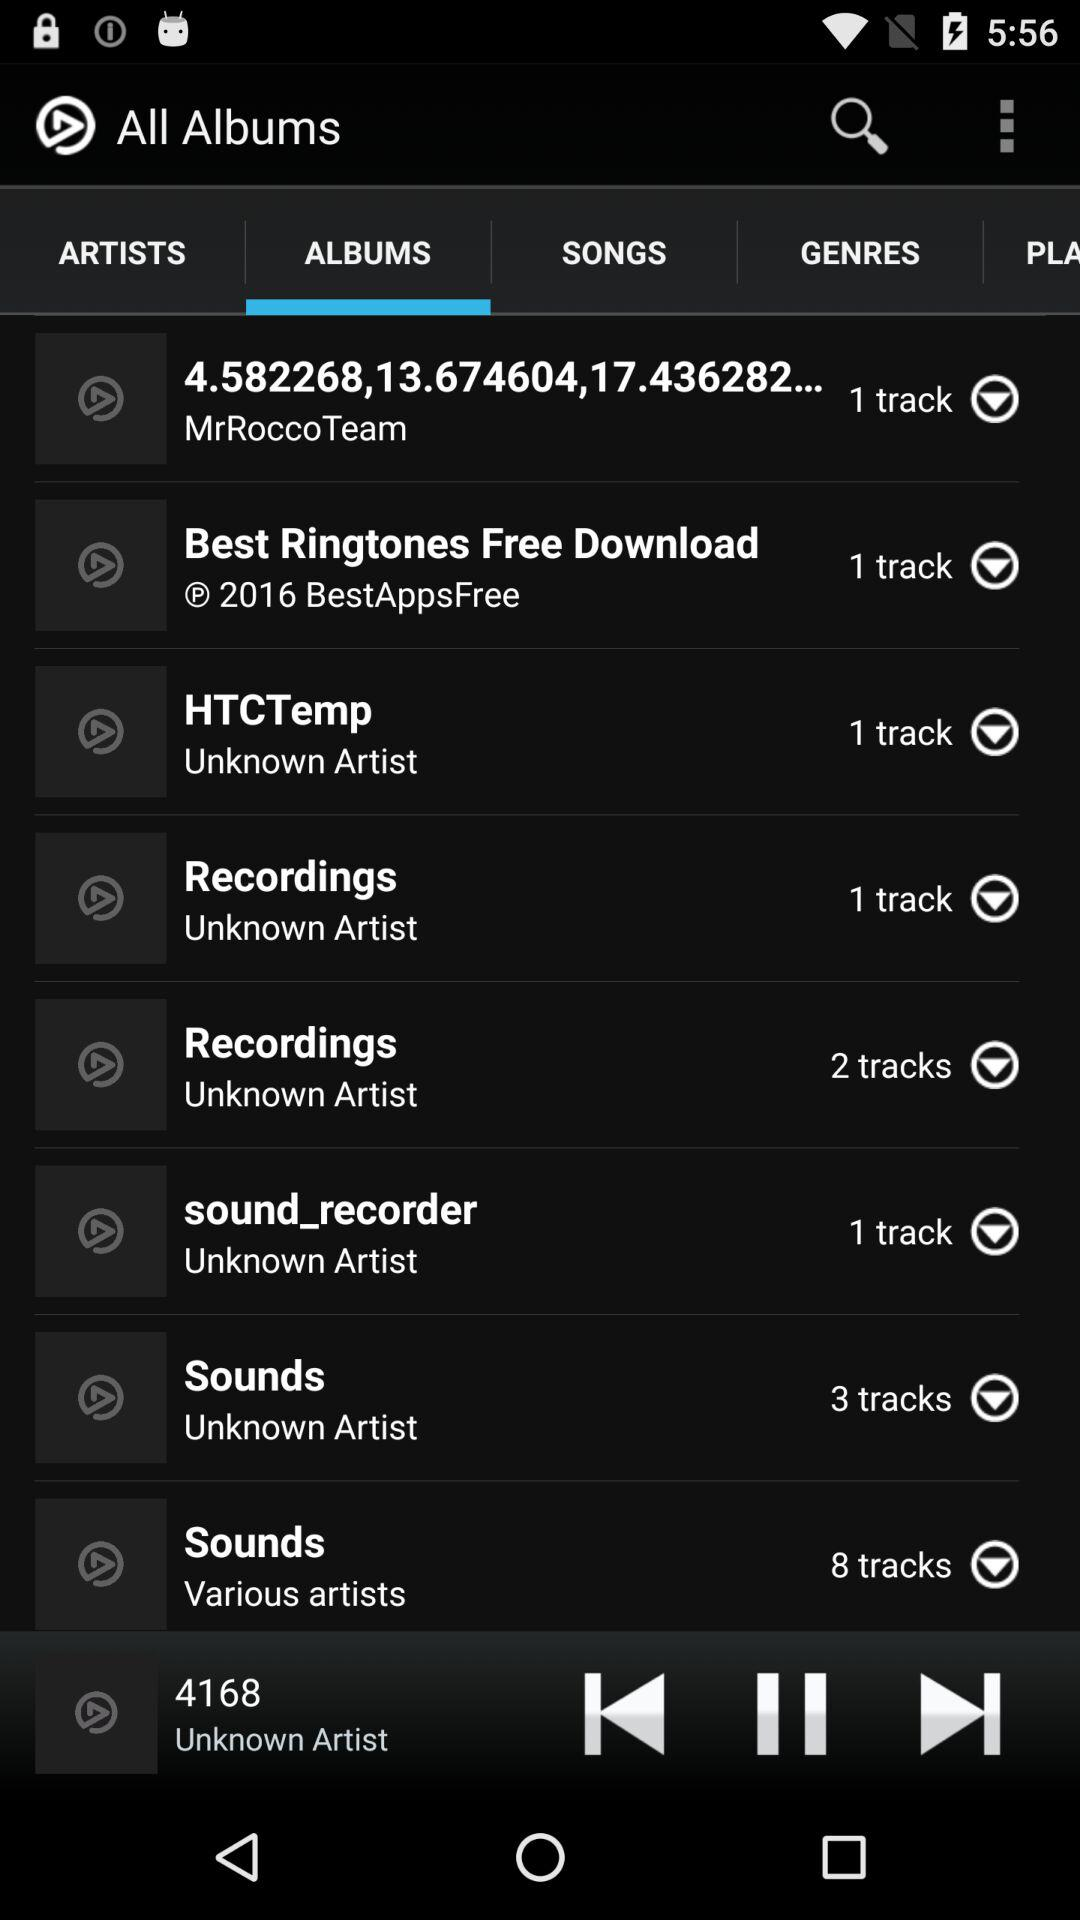Which album is playing? The album 4168 is currently playing. 